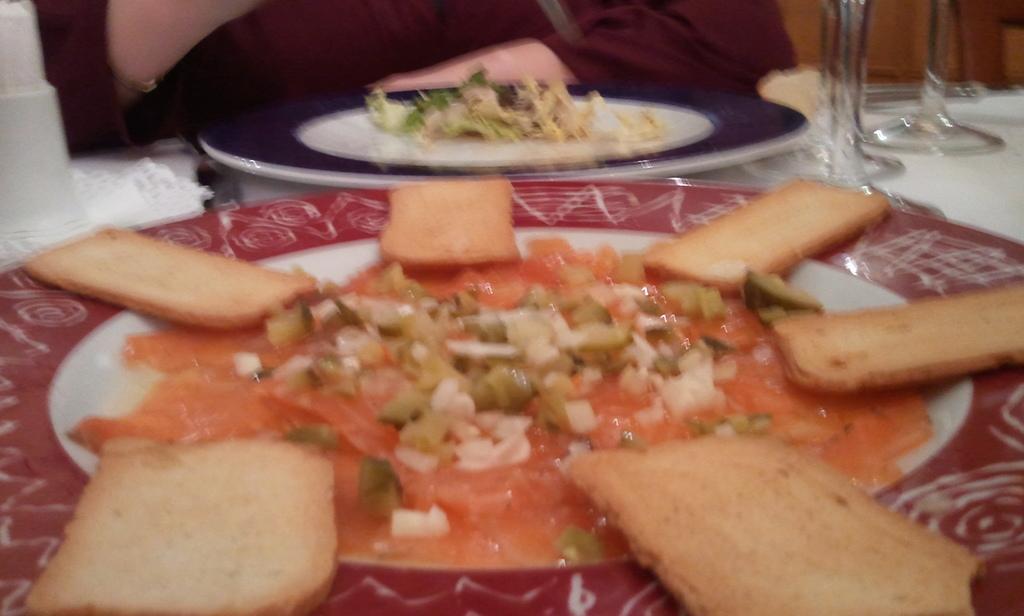In one or two sentences, can you explain what this image depicts? In this picture we can see plates with food items on it, glasses and these all are placed on a table. 